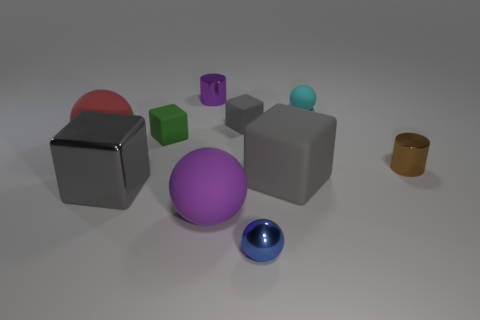What is the size of the other matte cube that is the same color as the large rubber block?
Offer a very short reply. Small. There is a purple thing that is the same shape as the cyan object; what size is it?
Your answer should be compact. Large. Is there any other thing that is the same size as the green matte object?
Provide a short and direct response. Yes. Are there fewer tiny metallic things behind the purple metal thing than large purple cubes?
Ensure brevity in your answer.  No. Do the big red rubber object and the big purple thing have the same shape?
Ensure brevity in your answer.  Yes. There is another tiny thing that is the same shape as the small cyan object; what is its color?
Your answer should be compact. Blue. What number of matte objects are the same color as the large matte block?
Your answer should be compact. 1. What number of things are big gray blocks that are to the left of the tiny metal sphere or tiny rubber things?
Your response must be concise. 4. What is the size of the rubber cube to the left of the big purple sphere?
Your answer should be compact. Small. Are there fewer purple objects than red balls?
Provide a short and direct response. No. 